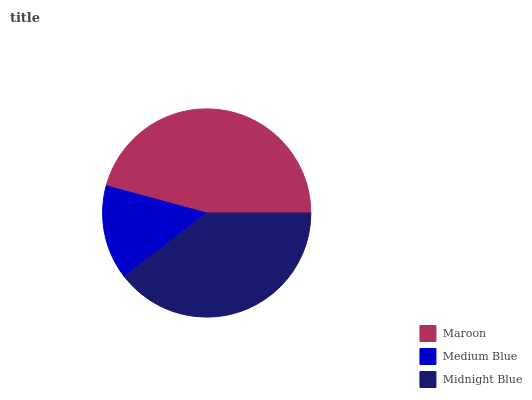Is Medium Blue the minimum?
Answer yes or no. Yes. Is Maroon the maximum?
Answer yes or no. Yes. Is Midnight Blue the minimum?
Answer yes or no. No. Is Midnight Blue the maximum?
Answer yes or no. No. Is Midnight Blue greater than Medium Blue?
Answer yes or no. Yes. Is Medium Blue less than Midnight Blue?
Answer yes or no. Yes. Is Medium Blue greater than Midnight Blue?
Answer yes or no. No. Is Midnight Blue less than Medium Blue?
Answer yes or no. No. Is Midnight Blue the high median?
Answer yes or no. Yes. Is Midnight Blue the low median?
Answer yes or no. Yes. Is Maroon the high median?
Answer yes or no. No. Is Maroon the low median?
Answer yes or no. No. 